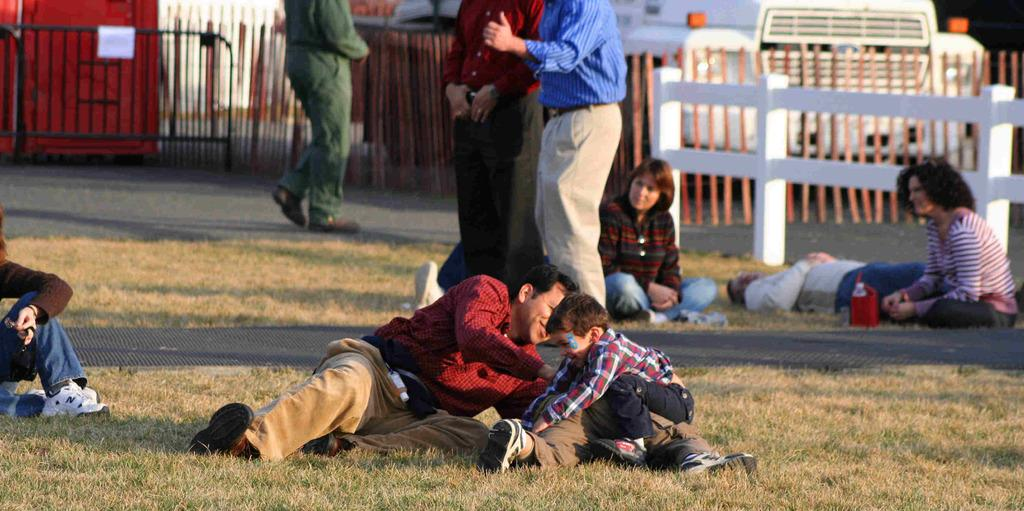How many people are in the image? There are people in the image, but the exact number is not specified. What type of terrain is visible in the image? There is grass visible in the image. What is inside the bag in the image? There is a bottle in a bag in the image. What type of structure is present in the image? There is a mesh in the image. What type of barrier is present in the image? There are fences and a barricade in the image. What can be seen in the background of the image? There is a vehicle in the background of the image. How many trees are in the image? There is no mention of trees in the image; only grass is specified. What type of bird is the hen in the image? There is no hen present in the image. Who is the owner of the vehicle in the background of the image? The image does not provide information about the owner of the vehicle. 